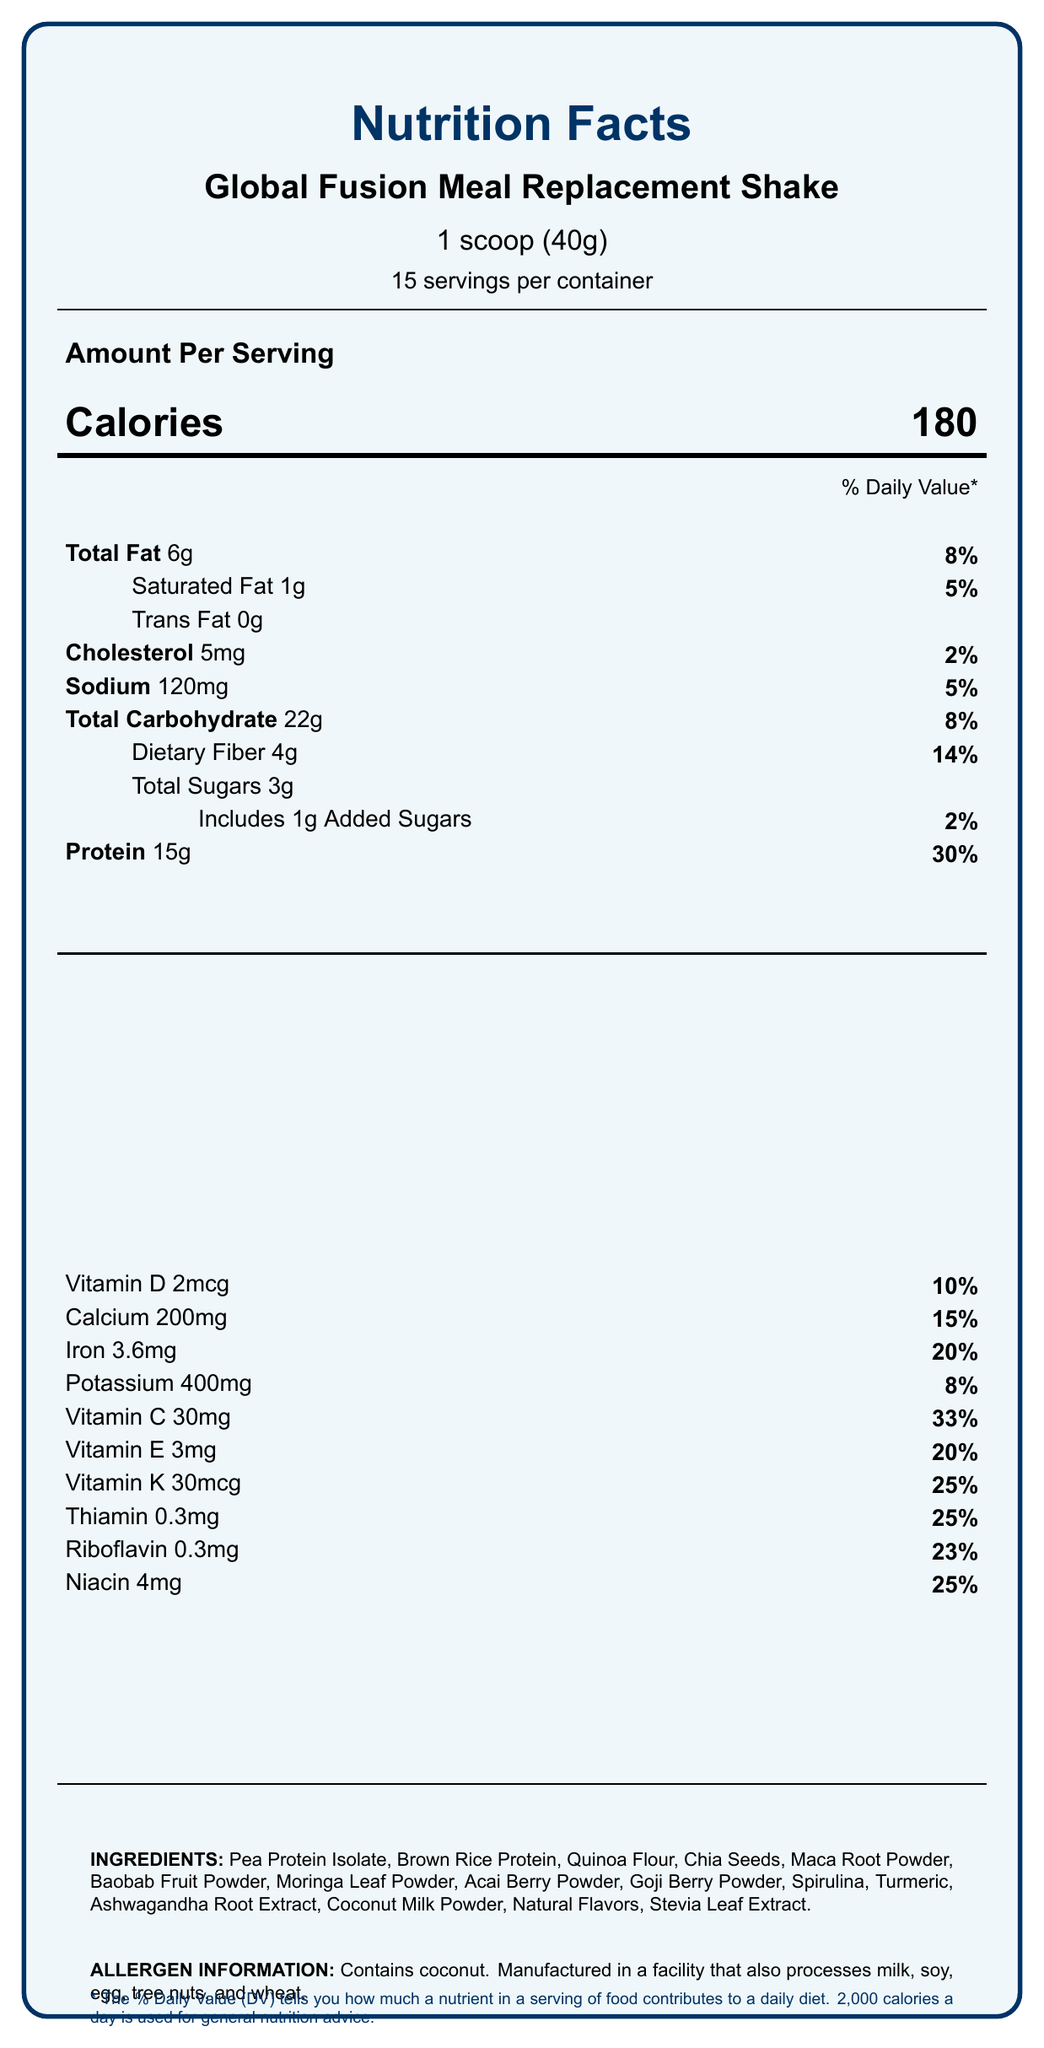what is the serving size of the Global Fusion Meal Replacement Shake? The serving size is listed under the product name on the label as "1 scoop (40g)."
Answer: 1 scoop (40g) how many calories are in one serving? The number of calories per serving is stated next to the word "Calories" as 180.
Answer: 180 what percentage of the daily value of protein does one serving provide? Next to "Protein," it states "15g" and indicates "30%" for the daily value.
Answer: 30% what is the total amount of dietary fiber in one serving? The amount of dietary fiber is listed under "Total Carbohydrate" as "Dietary Fiber 4g."
Answer: 4g which ingredient is used as a sweetener in the meal replacement shake? In the ingredients list, "Stevia Leaf Extract" is included, which is a common natural sweetener.
Answer: Stevia Leaf Extract how much vitamin D is in each serving and what percentage of the daily value does it provide? The document states "Vitamin D 2mcg" followed by "10%" for the daily value.
Answer: 2mcg, 10% which historical significance is associated with Baobab Fruit Powder? A. Known as 'Indian Ginseng' or 'Ashwagandha' B. Sacred grain of the Incas C. Called the 'Tree of Life' and used in African medicine According to the cultural significance section, Baobab is known as the 'Tree of Life' and used in traditional African medicine.
Answer: C what is the historical significance of Maca Root? A. Used in Ayurvedic medicine for 4,000 years B. Harvested by the Aztecs from Lake Texcoco C. Used by Incan warriors for strength and endurance The historical significance described for Maca Root is its use by Incan warriors for strength and endurance.
Answer: C is the Global Fusion Meal Replacement Shake manufactured in a facility that processes milk? The allergen information states it is manufactured in a facility that also processes milk.
Answer: Yes does each serving of the shake contain any trans fat? The nutrition facts label lists "Trans Fat 0g" which means there is no trans fat in each serving.
Answer: No summarize the main nutritional features and cultural background of the Global Fusion Meal Replacement Shake. The summary includes key nutritional information (calories, macronutrients, vitamins, and minerals) and highlights the cultural significance of various ingredients. This overall description captures the essence of both nutritional value and cultural importance.
Answer: This meal replacement shake provides 180 calories per serving and contains 6g of total fat (8% DV), 22g of carbohydrate (8% DV), 15g of protein (30% DV), various vitamins and minerals, and additional nutrients. The ingredients include culturally significant items like Quinoa, Maca Root, Baobab, and more, each with a notable historical background. how many grams of added sugars are in one serving of the shake? Under "Total Sugars," it states "Includes 1g Added Sugars."
Answer: 1g which ingredient originates from the Amazon rainforest and is believed to have life-extending properties? The cultural significance section notes that Acai Berry originates from the Amazon rainforest and is believed to have life-extending properties by indigenous tribes.
Answer: Acai Berry based on the provided document, what is the historical significance of Spirulina? The cultural significance section describes Spirulina's historical use by the Aztecs from Lake Texcoco.
Answer: Harvested by the Aztecs from Lake Texcoco, called 'tecuitlatl' what's the total serving size of Global Fusion Meal Replacement Shake per container? A. 400g B. 600g C. 500g D. 800g Each scoop is 40g, and there are 15 servings per container. 40g x 15 = 600g, so the total serving size per container is 600g.
Answer: B how many different vitamins are listed in the vitamins and minerals section? The vitamins and minerals section lists Vitamin D, Calcium, Iron, Potassium, Vitamin C, Vitamin E, Vitamin K, Thiamin, Riboflavin, Niacin, Vitamin B6, Folate, Vitamin B12, Biotin, Pantothenic Acid, and Magnesium, making a total of 16 different vitamins and minerals.
Answer: 16 are chia seeds included in the ingredients? Chia Seeds are listed within the ingredients section.
Answer: Yes what is the daily value percentage of zinc provided by a single serving? In the additional nutrients section, it is stated that Zinc provides 2.8mg and 25% of the daily value.
Answer: 25% what is the origin of Goji Berries and their historical significance? The cultural significance section explains that Goji Berries originate from China and have been used in Traditional Chinese Medicine for over 2,000 years, being associated with longevity.
Answer: China, Used in Traditional Chinese Medicine for over 2,000 years, associated with longevity what are the main ingredients in the Global Fusion Meal Replacement Shake? The list of ingredients provided in the label includes all these items.
Answer: Pea Protein Isolate, Brown Rice Protein, Quinoa Flour, Chia Seeds, Maca Root Powder, Baobab Fruit Powder, Moringa Leaf Powder, Acai Berry Powder, Goji Berry Powder, Spirulina, Turmeric, Ashwagandha Root Extract, Coconut Milk Powder, Natural Flavors, Stevia Leaf Extract 